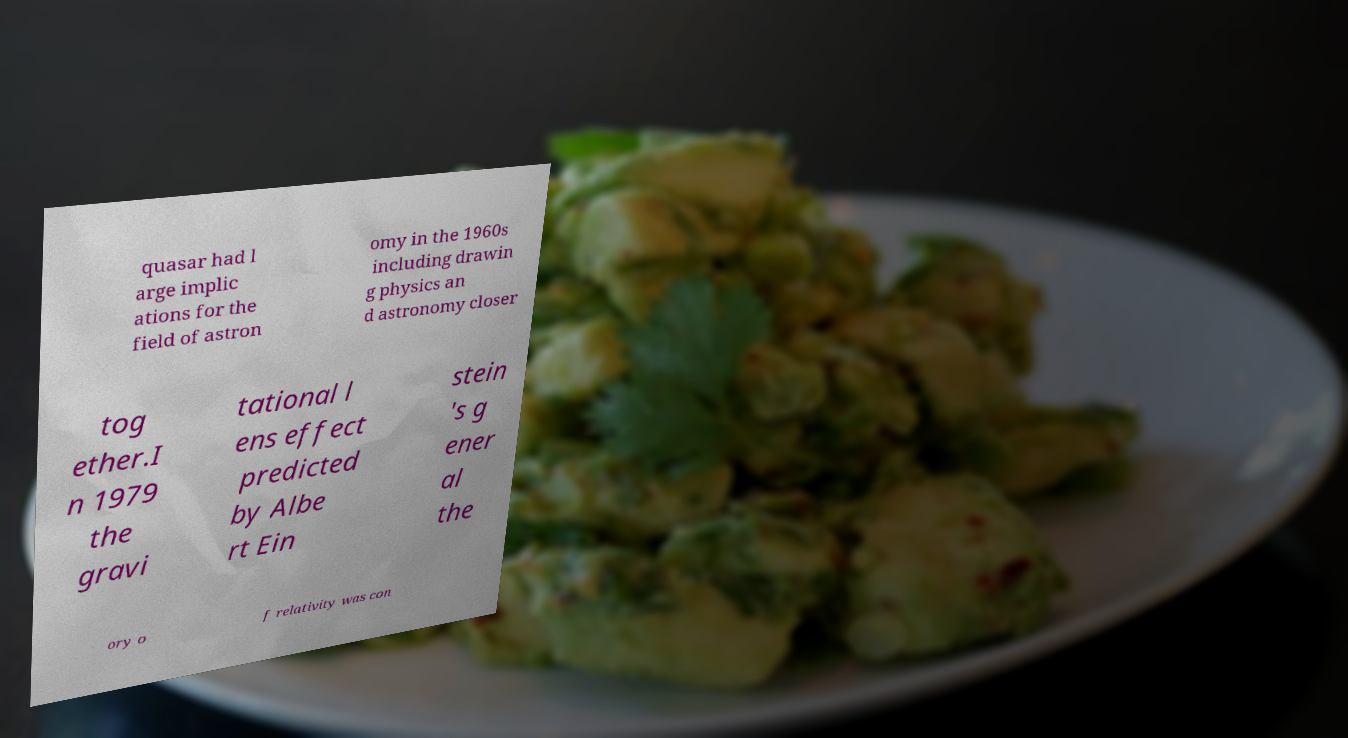There's text embedded in this image that I need extracted. Can you transcribe it verbatim? quasar had l arge implic ations for the field of astron omy in the 1960s including drawin g physics an d astronomy closer tog ether.I n 1979 the gravi tational l ens effect predicted by Albe rt Ein stein 's g ener al the ory o f relativity was con 